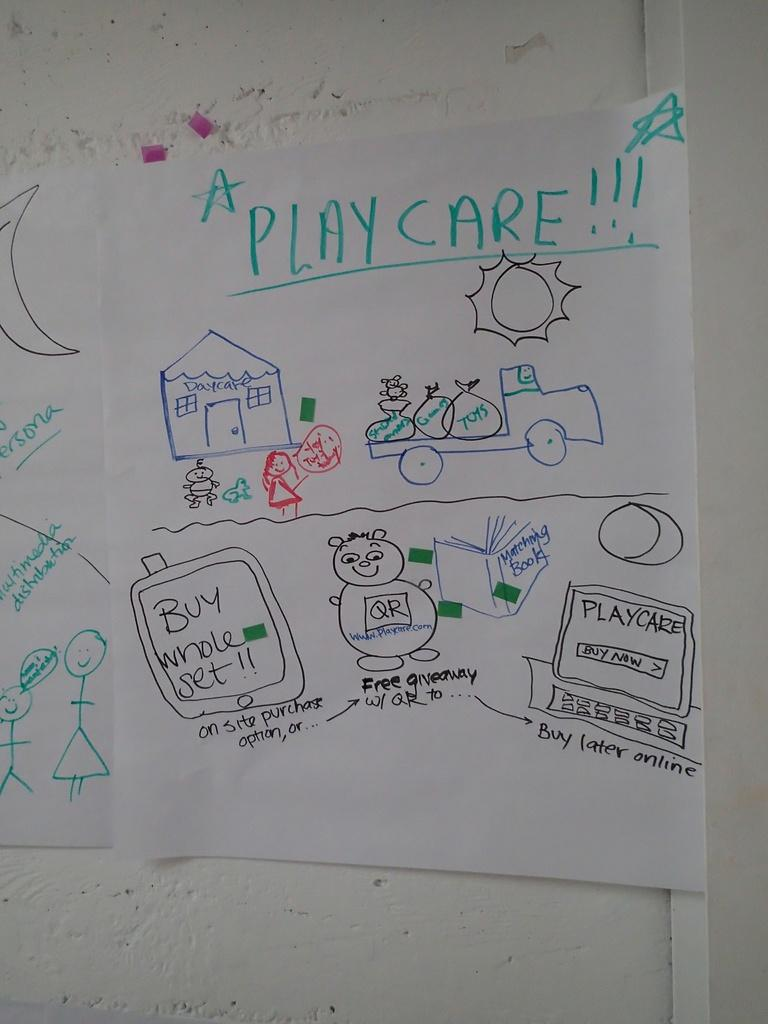<image>
Render a clear and concise summary of the photo. a sign for Play Care is taped to a wall 